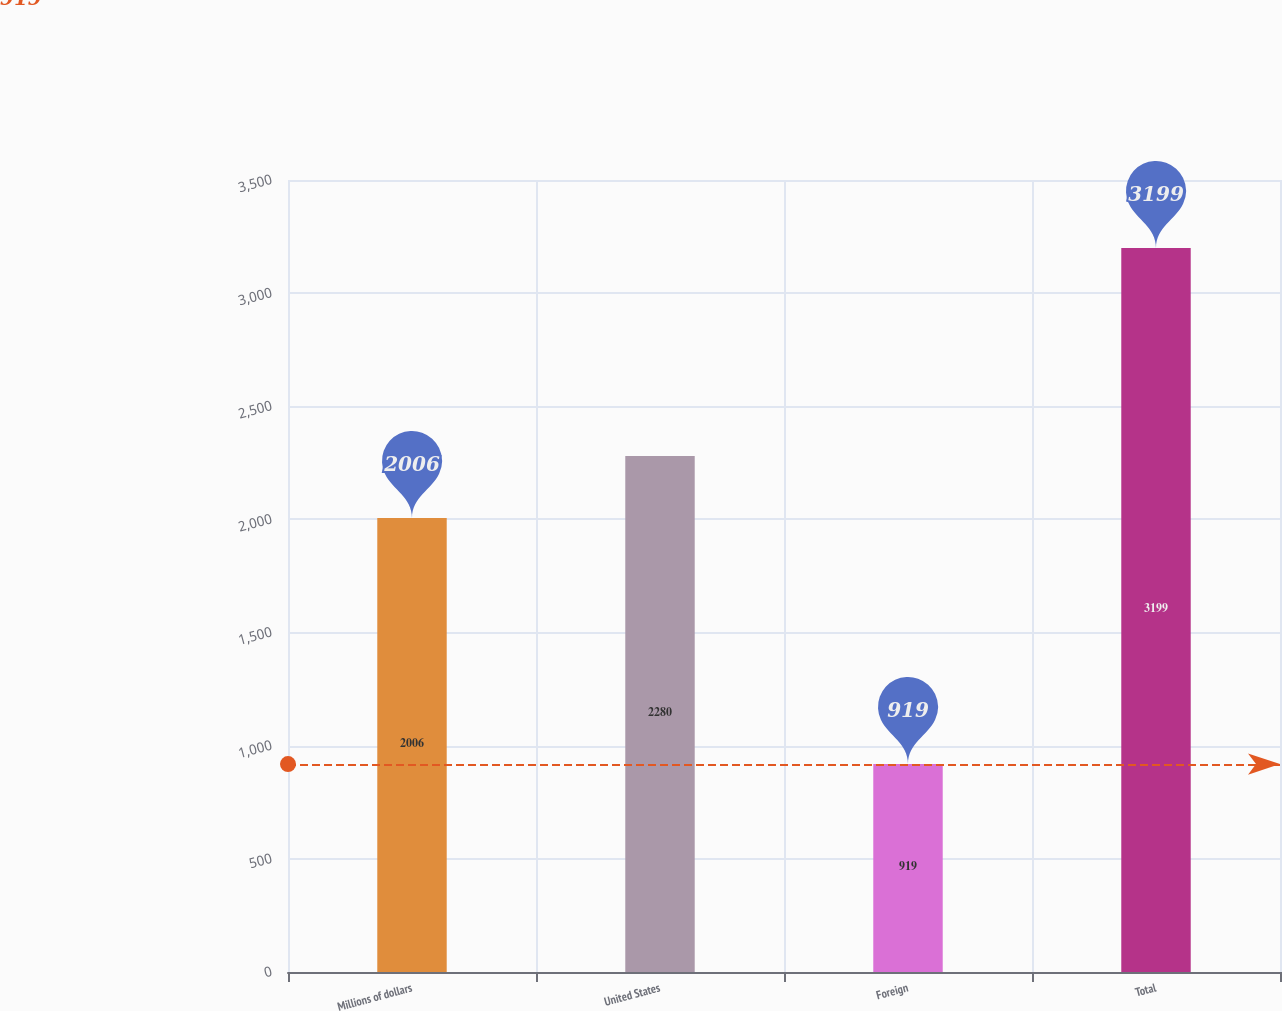Convert chart to OTSL. <chart><loc_0><loc_0><loc_500><loc_500><bar_chart><fcel>Millions of dollars<fcel>United States<fcel>Foreign<fcel>Total<nl><fcel>2006<fcel>2280<fcel>919<fcel>3199<nl></chart> 